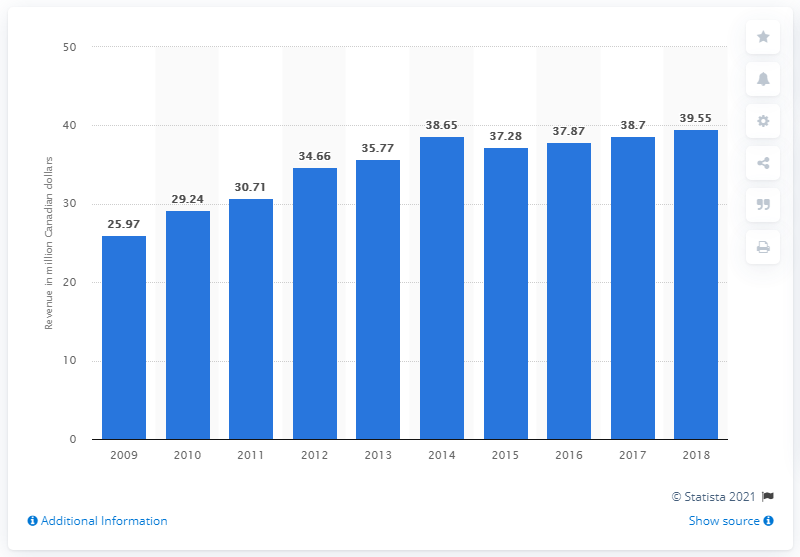Outline some significant characteristics in this image. In 2018, the Canadian trucking industry generated approximately CAD 39.55 billion in revenue. 